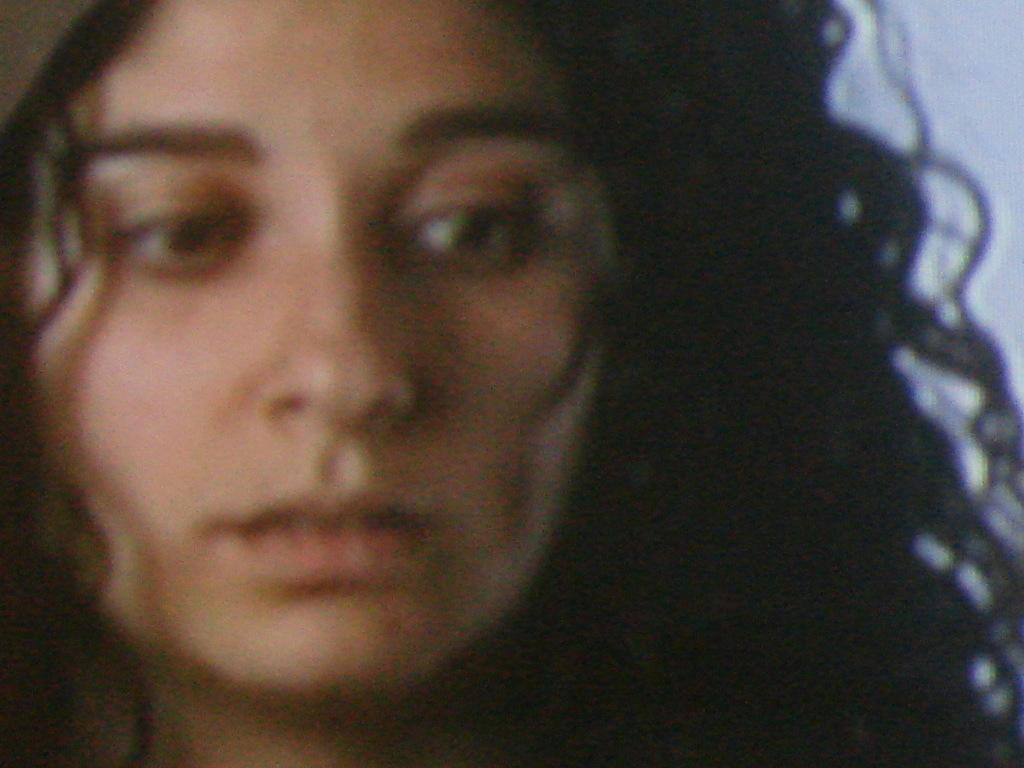What is the main subject of the image? The main subject of the image is a woman. Can you describe the woman's position in the image? The woman is in the middle of the image. What type of instrument does the woman use to play music in the image? There is no indication in the image that the woman is playing any musical instrument. 